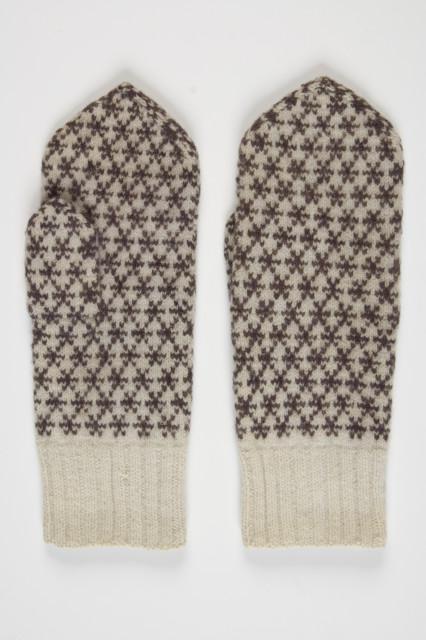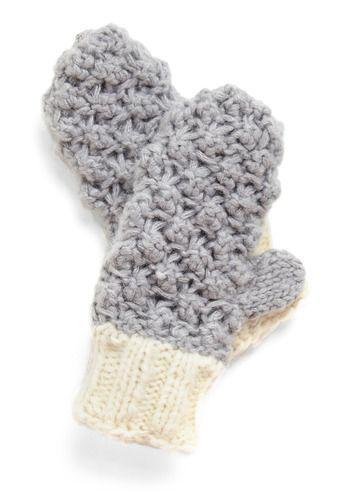The first image is the image on the left, the second image is the image on the right. Considering the images on both sides, is "The image contains fingerless mittens/gloves." valid? Answer yes or no. No. The first image is the image on the left, the second image is the image on the right. Examine the images to the left and right. Is the description "There is at least one pair of convertible fingerless gloves." accurate? Answer yes or no. No. 